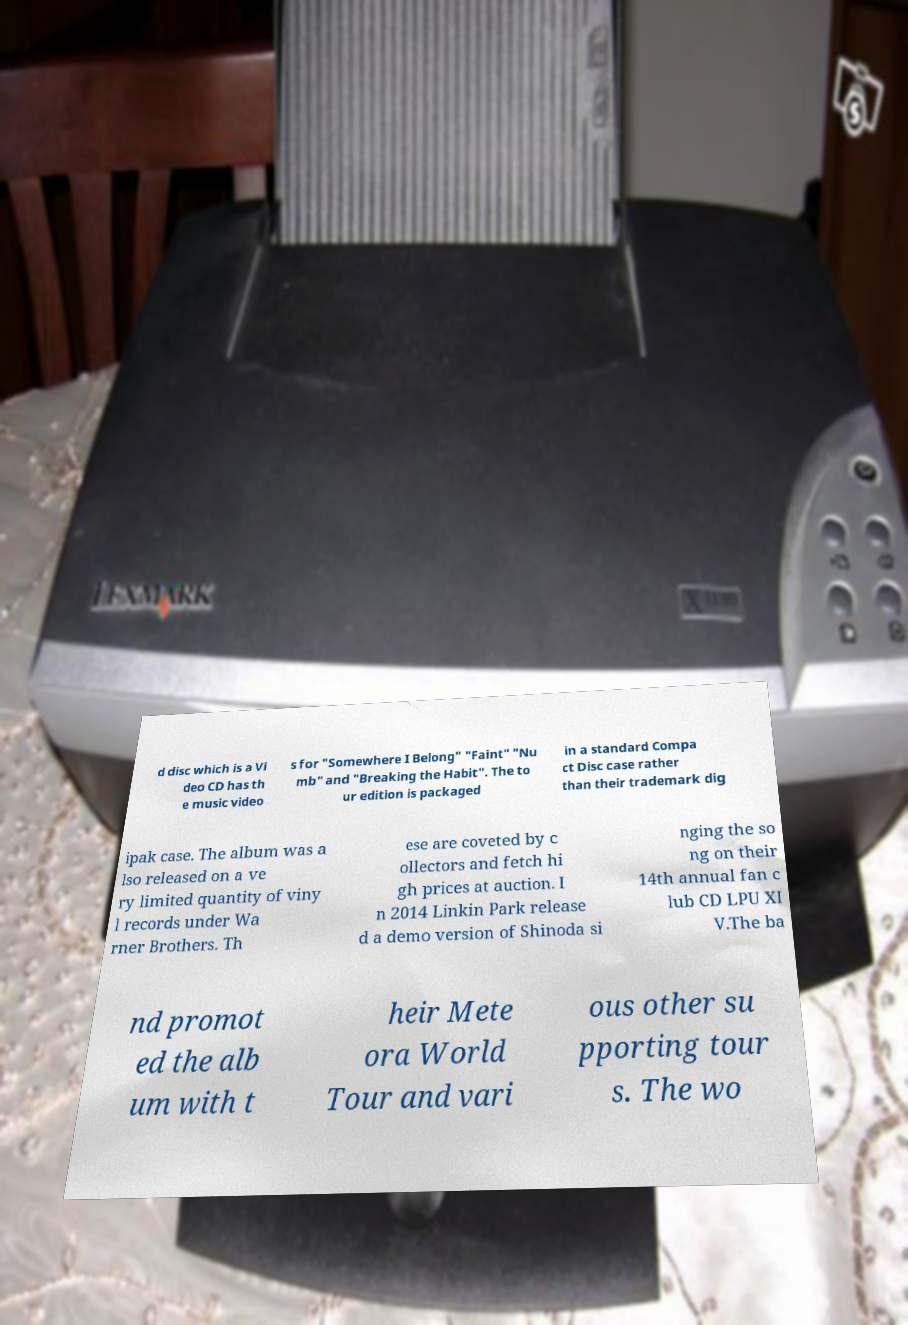Could you assist in decoding the text presented in this image and type it out clearly? d disc which is a Vi deo CD has th e music video s for "Somewhere I Belong" "Faint" "Nu mb" and "Breaking the Habit". The to ur edition is packaged in a standard Compa ct Disc case rather than their trademark dig ipak case. The album was a lso released on a ve ry limited quantity of viny l records under Wa rner Brothers. Th ese are coveted by c ollectors and fetch hi gh prices at auction. I n 2014 Linkin Park release d a demo version of Shinoda si nging the so ng on their 14th annual fan c lub CD LPU XI V.The ba nd promot ed the alb um with t heir Mete ora World Tour and vari ous other su pporting tour s. The wo 